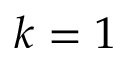Convert formula to latex. <formula><loc_0><loc_0><loc_500><loc_500>k = 1</formula> 